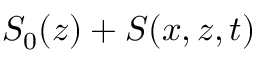<formula> <loc_0><loc_0><loc_500><loc_500>S _ { 0 } ( z ) + S ( x , z , t )</formula> 